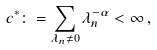<formula> <loc_0><loc_0><loc_500><loc_500>c ^ { * } \colon = \sum _ { \lambda _ { n } \ne 0 } \lambda _ { n } ^ { - \alpha } < \infty \, ,</formula> 